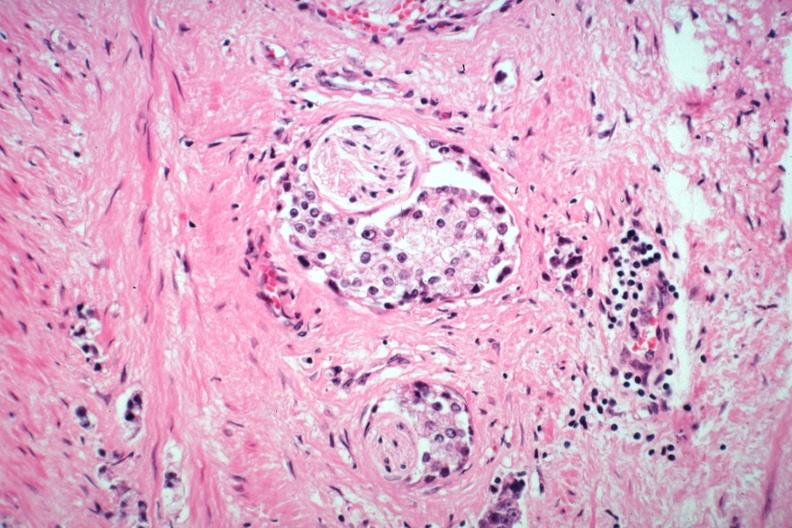what is present?
Answer the question using a single word or phrase. Adenocarcinoma 